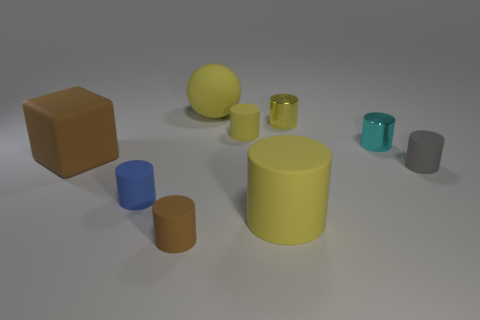How many yellow cylinders must be subtracted to get 1 yellow cylinders? 2 Subtract all small yellow metallic cylinders. How many cylinders are left? 6 Subtract all cyan cylinders. How many cylinders are left? 6 Subtract 2 cylinders. How many cylinders are left? 5 Subtract 0 green cylinders. How many objects are left? 9 Subtract all balls. How many objects are left? 8 Subtract all purple blocks. Subtract all cyan balls. How many blocks are left? 1 Subtract all red cubes. How many blue cylinders are left? 1 Subtract all small blue cylinders. Subtract all big cubes. How many objects are left? 7 Add 8 gray things. How many gray things are left? 9 